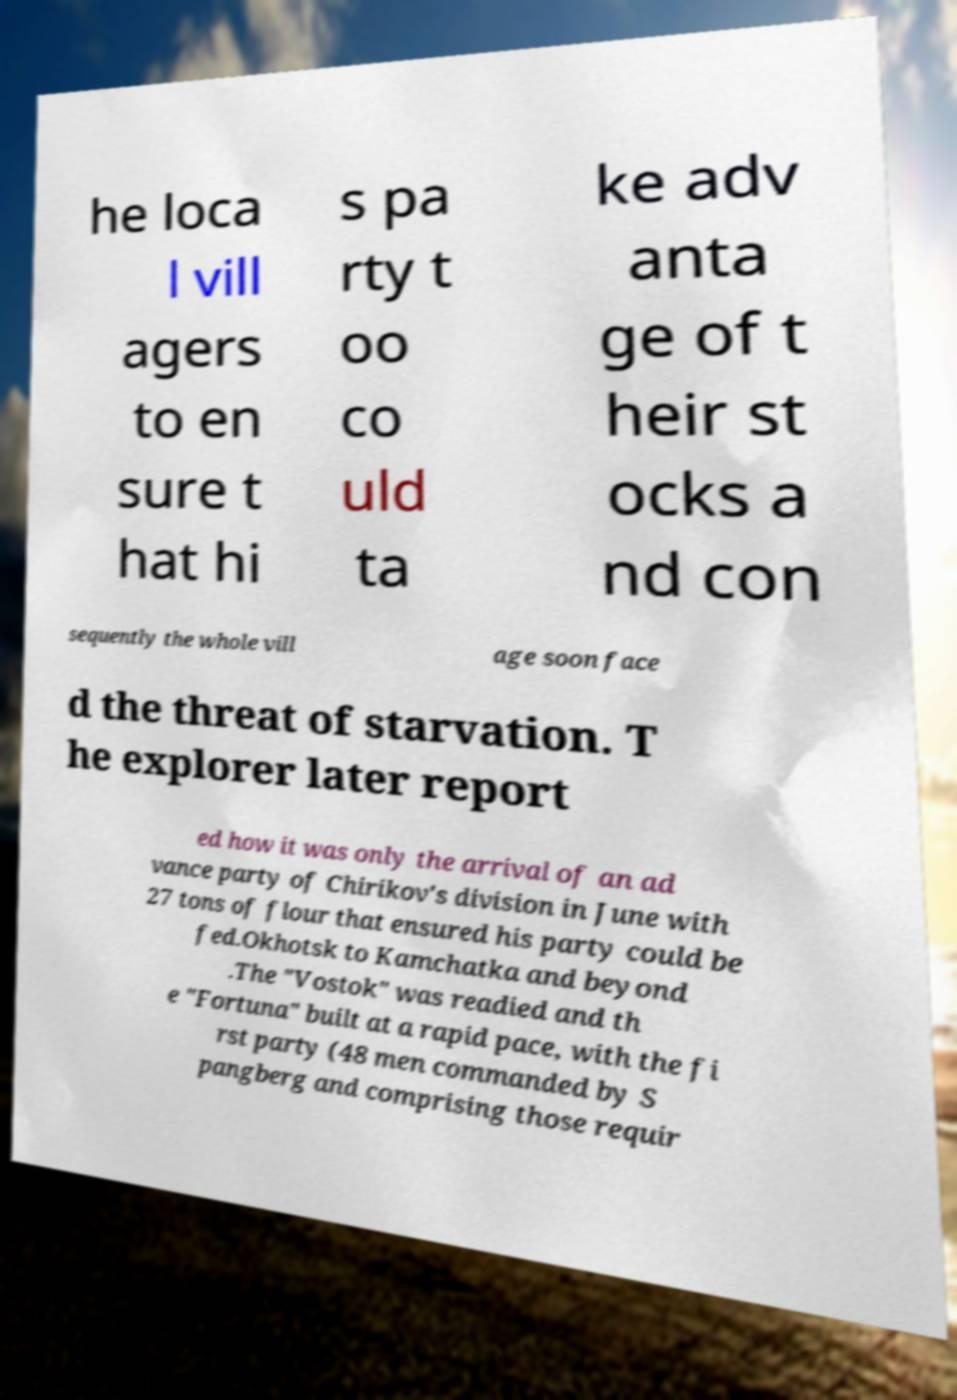I need the written content from this picture converted into text. Can you do that? he loca l vill agers to en sure t hat hi s pa rty t oo co uld ta ke adv anta ge of t heir st ocks a nd con sequently the whole vill age soon face d the threat of starvation. T he explorer later report ed how it was only the arrival of an ad vance party of Chirikov's division in June with 27 tons of flour that ensured his party could be fed.Okhotsk to Kamchatka and beyond .The "Vostok" was readied and th e "Fortuna" built at a rapid pace, with the fi rst party (48 men commanded by S pangberg and comprising those requir 